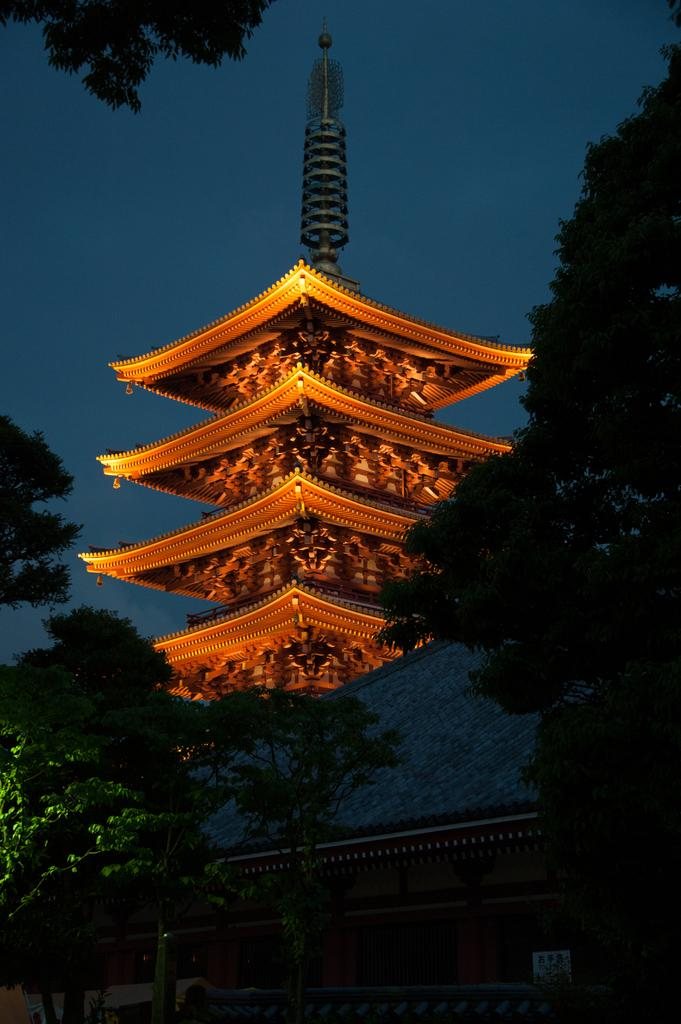What type of vegetation can be seen in the image? There are trees in the image. What type of structure is visible in the image? There is a Chinese construction building with lights in the image. What part of the natural environment is visible in the image? The sky is visible in the image. What type of paper is being used to rest on in the image? There is no paper present in the image for resting on. What type of work is being done on the construction building in the image? The image does not show any work being done on the construction building; it only shows the building with lights. 